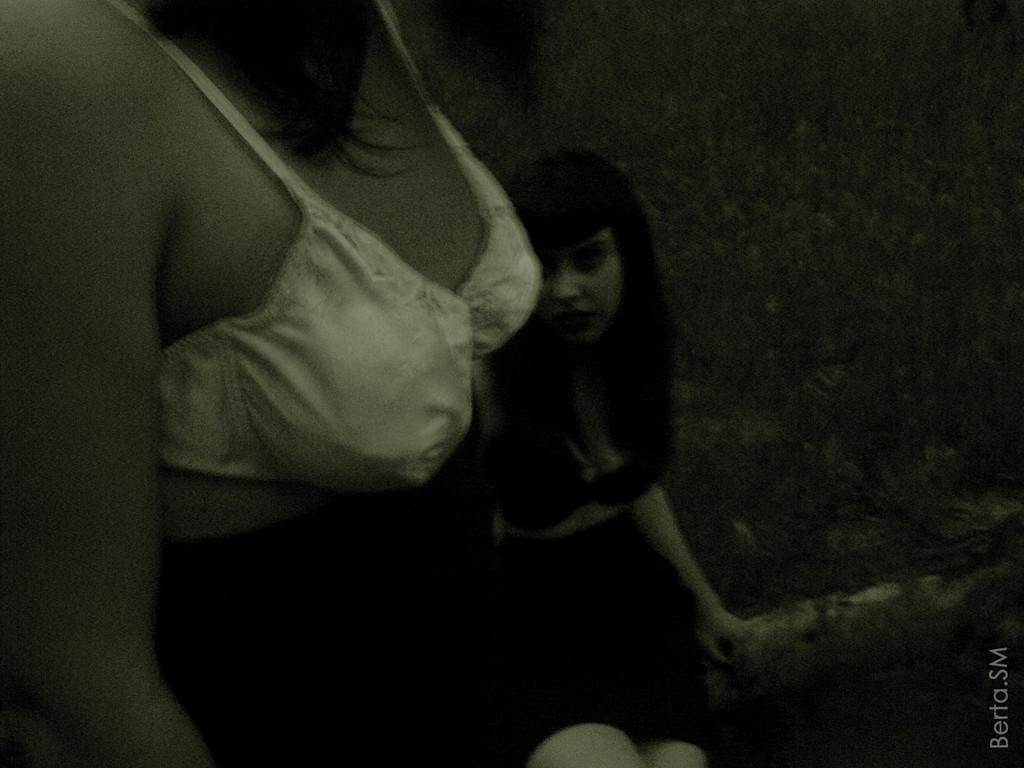In one or two sentences, can you explain what this image depicts? This is a black and white picture. I can see two persons, and there is dark background and there is a watermark on the image. 